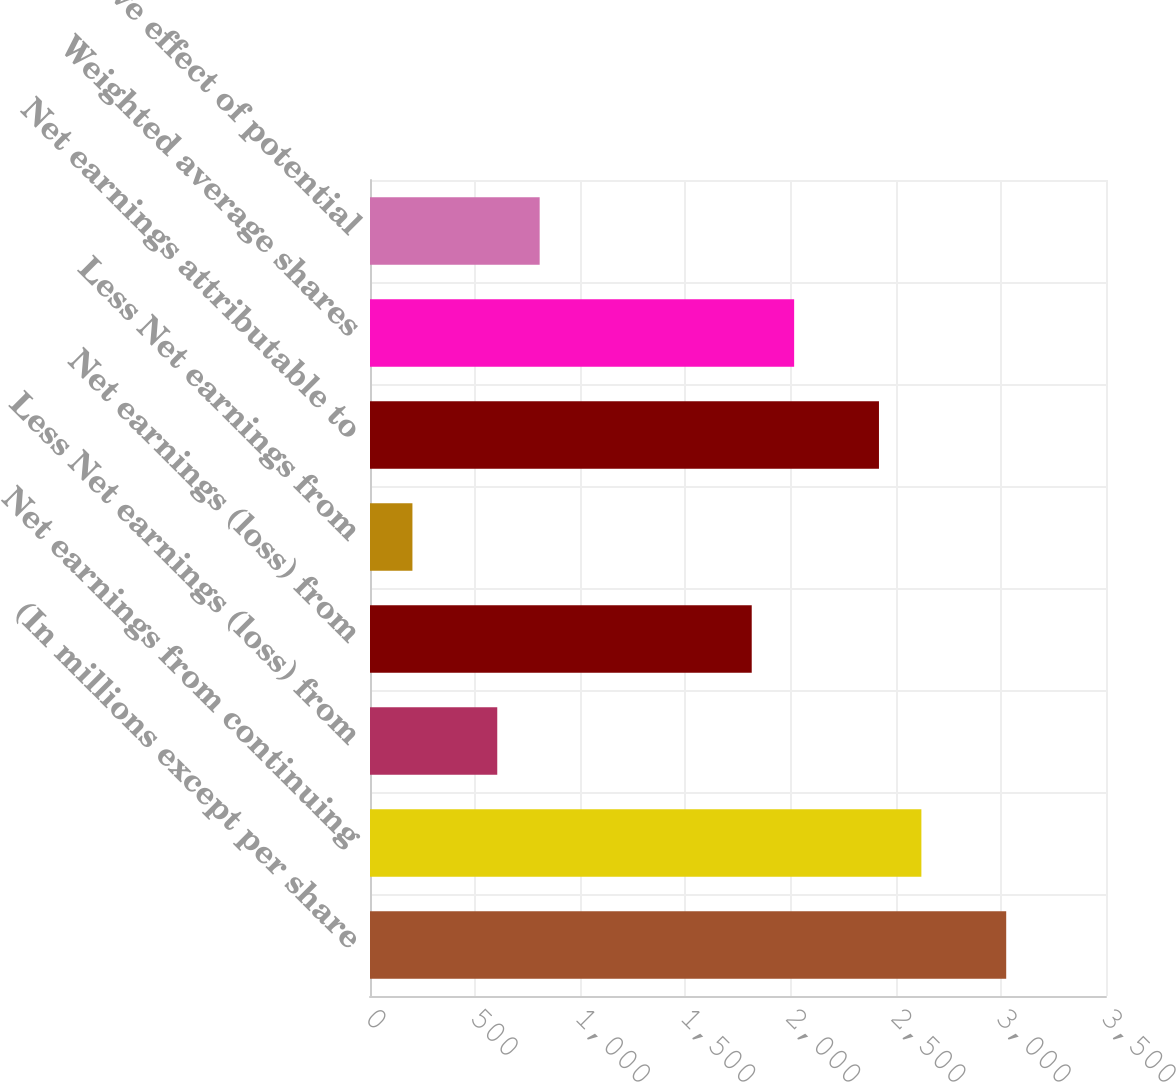Convert chart. <chart><loc_0><loc_0><loc_500><loc_500><bar_chart><fcel>(In millions except per share<fcel>Net earnings from continuing<fcel>Less Net earnings (loss) from<fcel>Net earnings (loss) from<fcel>Less Net earnings from<fcel>Net earnings attributable to<fcel>Weighted average shares<fcel>Dilutive effect of potential<nl><fcel>3025.43<fcel>2622.05<fcel>605.15<fcel>1815.29<fcel>201.77<fcel>2420.36<fcel>2016.98<fcel>806.84<nl></chart> 